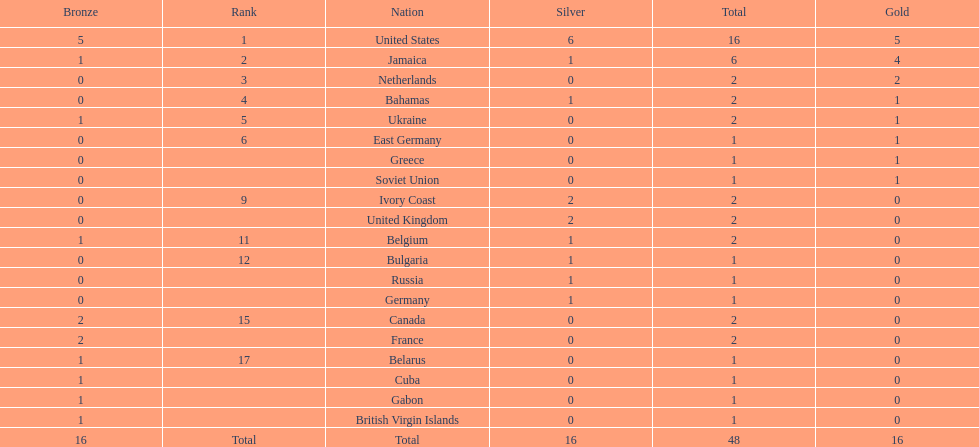Could you parse the entire table as a dict? {'header': ['Bronze', 'Rank', 'Nation', 'Silver', 'Total', 'Gold'], 'rows': [['5', '1', 'United States', '6', '16', '5'], ['1', '2', 'Jamaica', '1', '6', '4'], ['0', '3', 'Netherlands', '0', '2', '2'], ['0', '4', 'Bahamas', '1', '2', '1'], ['1', '5', 'Ukraine', '0', '2', '1'], ['0', '6', 'East Germany', '0', '1', '1'], ['0', '', 'Greece', '0', '1', '1'], ['0', '', 'Soviet Union', '0', '1', '1'], ['0', '9', 'Ivory Coast', '2', '2', '0'], ['0', '', 'United Kingdom', '2', '2', '0'], ['1', '11', 'Belgium', '1', '2', '0'], ['0', '12', 'Bulgaria', '1', '1', '0'], ['0', '', 'Russia', '1', '1', '0'], ['0', '', 'Germany', '1', '1', '0'], ['2', '15', 'Canada', '0', '2', '0'], ['2', '', 'France', '0', '2', '0'], ['1', '17', 'Belarus', '0', '1', '0'], ['1', '', 'Cuba', '0', '1', '0'], ['1', '', 'Gabon', '0', '1', '0'], ['1', '', 'British Virgin Islands', '0', '1', '0'], ['16', 'Total', 'Total', '16', '48', '16']]} Following the united states, which nation secured the most gold medals? Jamaica. 